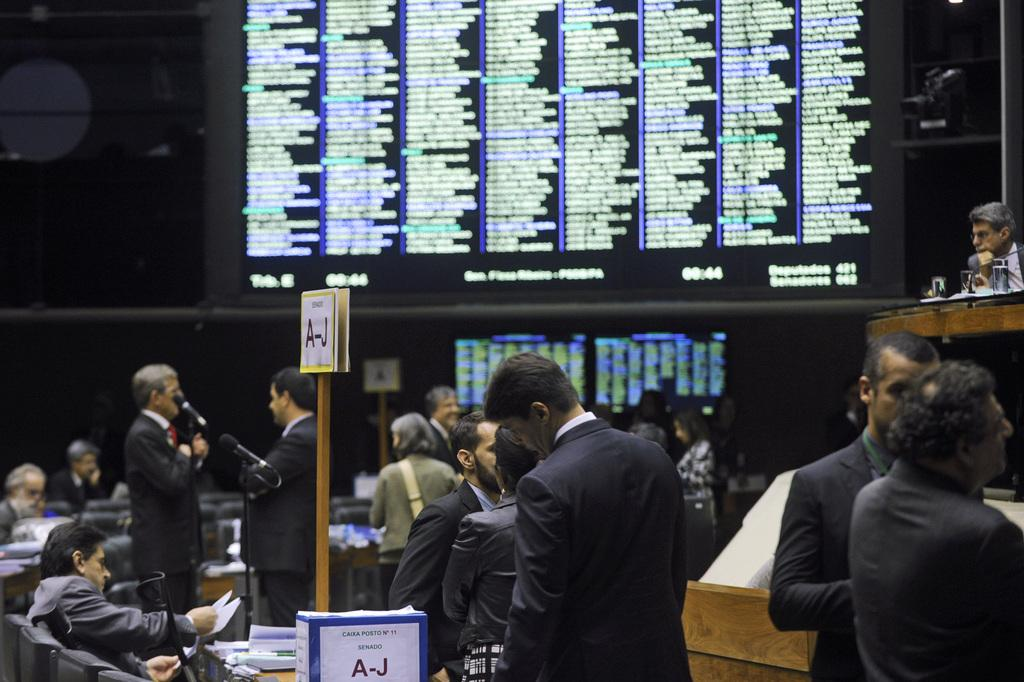Where was the image taken? The image was taken in a room. What is happening in the room? There is a group of people in the room, with some sitting and others standing. What can be seen behind the people? There is a screen behind the people. What type of brass instrument is being played by the people in the image? There is no brass instrument present in the image. What is the aftermath of the event depicted in the image? The image does not depict an event, so there is no aftermath to describe. 